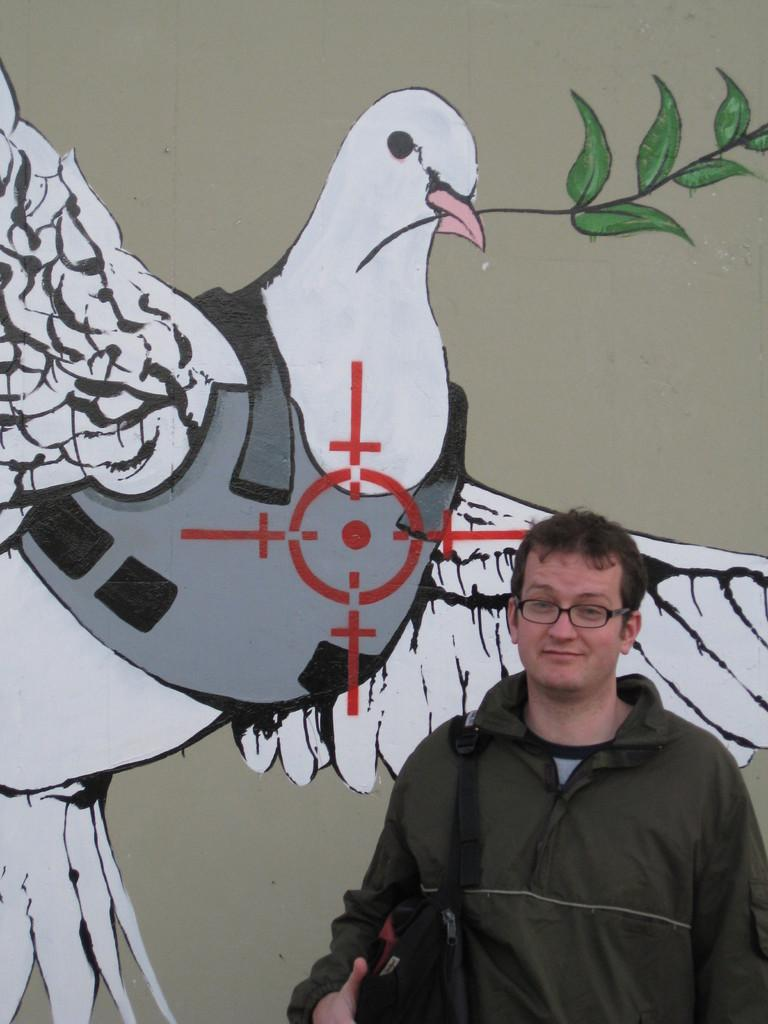What is the main subject of the image? There is a man standing in the image. What is the man wearing? The man is wearing a bag. What can be seen in the background of the image? There is a wall in the background of the image. What is on the wall in the background? There is a painting on the wall in the background. What type of fear can be seen on the man's face in the image? There is no indication of fear on the man's face in the image. Is the man wearing a scarf in the image? The provided facts do not mention a scarf; the man is wearing a bag. 